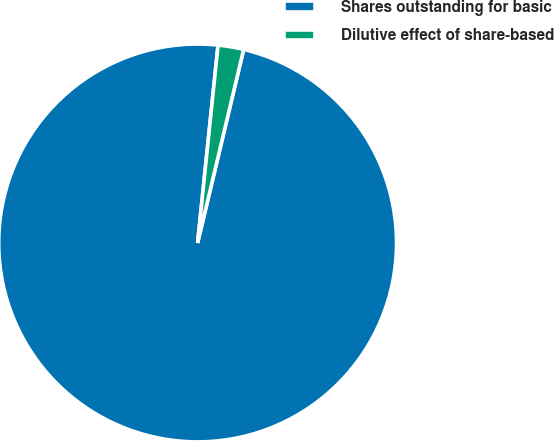Convert chart to OTSL. <chart><loc_0><loc_0><loc_500><loc_500><pie_chart><fcel>Shares outstanding for basic<fcel>Dilutive effect of share-based<nl><fcel>97.92%<fcel>2.08%<nl></chart> 